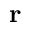Convert formula to latex. <formula><loc_0><loc_0><loc_500><loc_500>r</formula> 